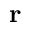Convert formula to latex. <formula><loc_0><loc_0><loc_500><loc_500>r</formula> 